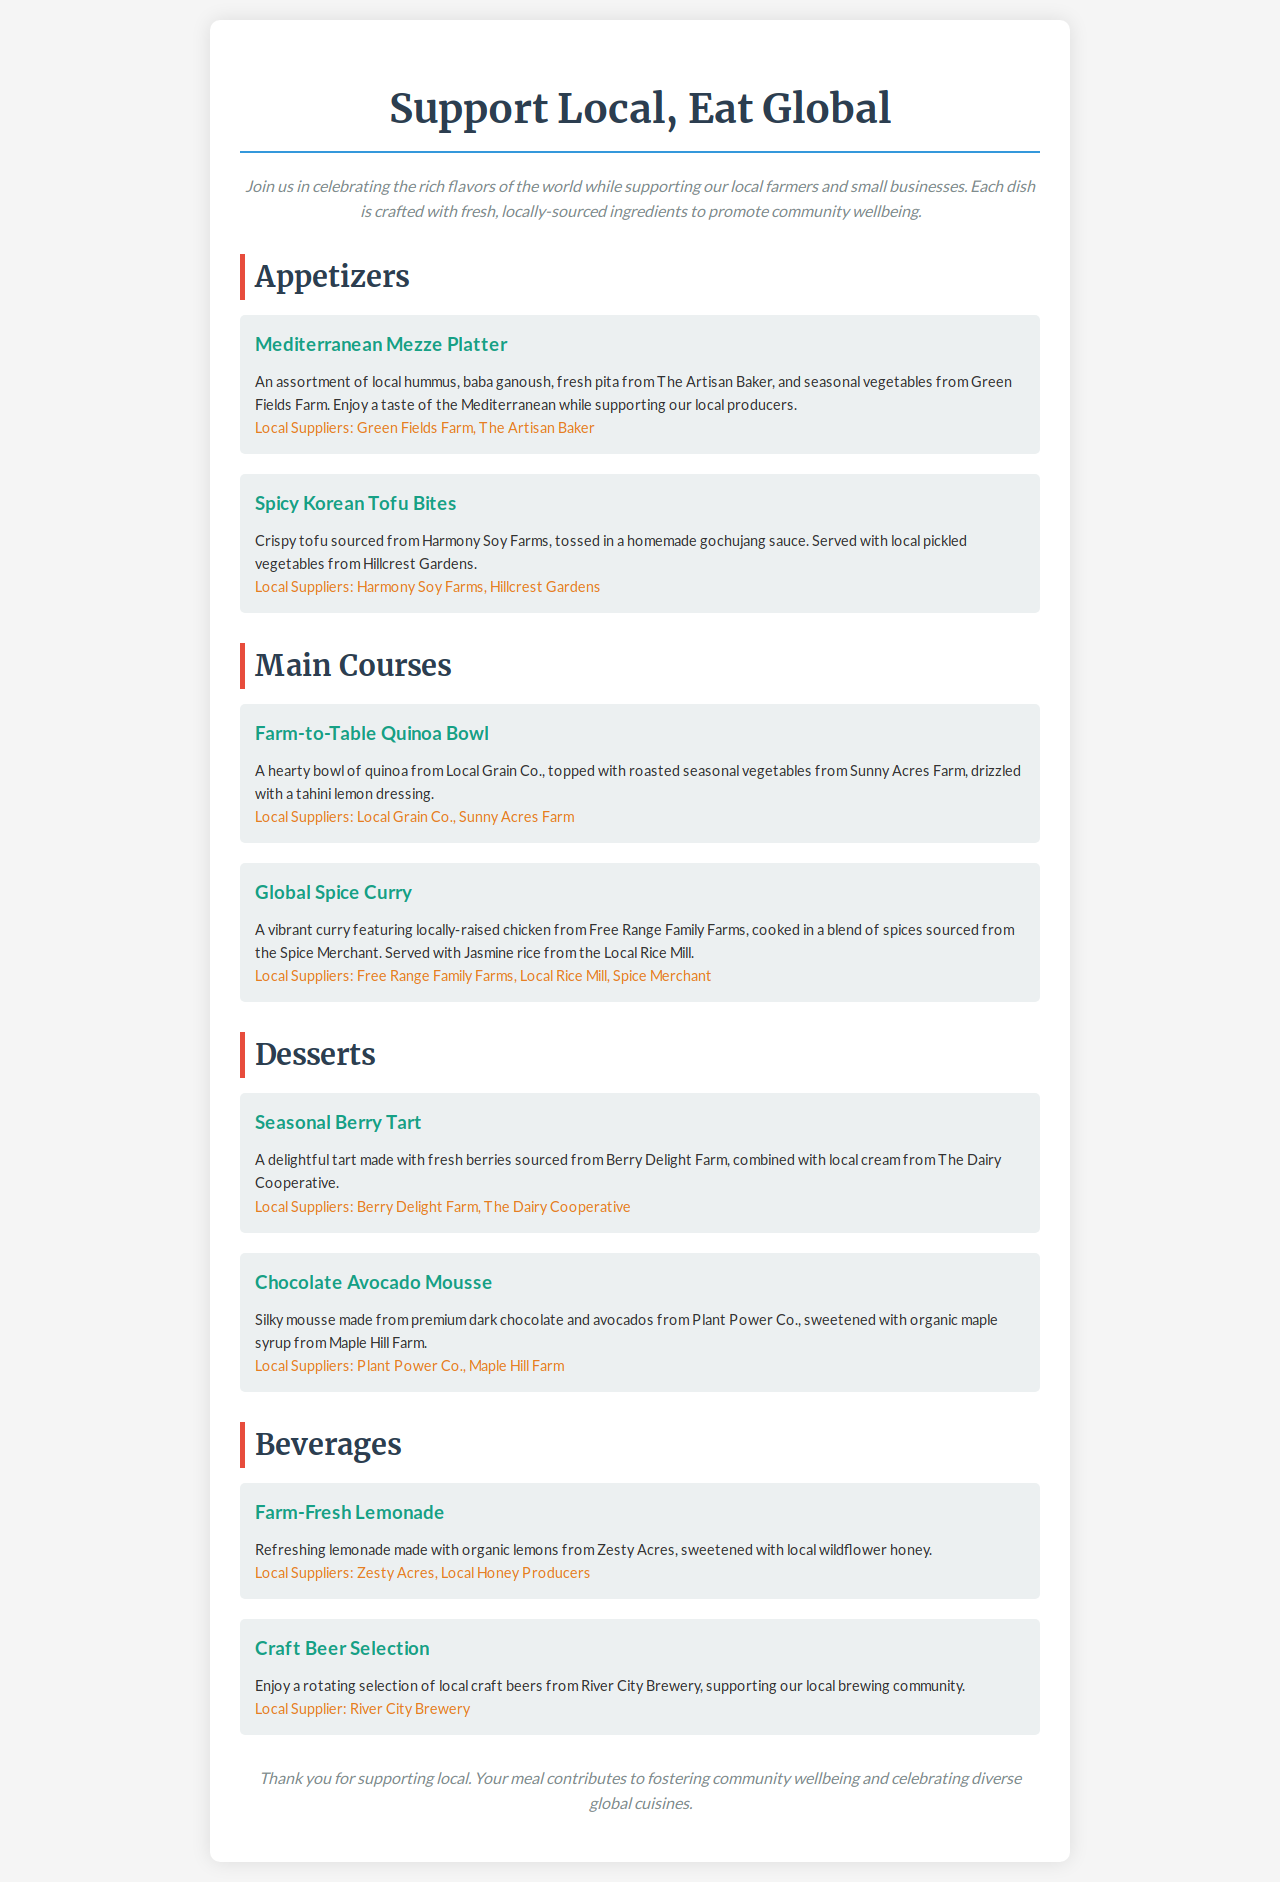What is the title of the menu? The title of the menu is prominently displayed at the top of the document, indicating the theme of the dining experience.
Answer: Support Local, Eat Global Who provides the fresh pita for the Mediterranean Mezze Platter? The supplier for the fresh pita is mentioned under the description of the Mediterranean Mezze Platter.
Answer: The Artisan Baker What kind of dressing is used in the Farm-to-Table Quinoa Bowl? The type of dressing is specified in the dish description for the Farm-to-Table Quinoa Bowl.
Answer: Tahini lemon dressing Which farm supplies the fresh berries for the Seasonal Berry Tart? The farm providing the fresh berries is stated in the description of the Seasonal Berry Tart.
Answer: Berry Delight Farm How many local suppliers are mentioned for the Global Spice Curry? The number of local suppliers is counted based on the listing in the Global Spice Curry item.
Answer: Three What does the Farm-Fresh Lemonade contain? The ingredients for the Farm-Fresh Lemonade are detailed in its description.
Answer: Organic lemons and local wildflower honey Which section comes after Appetizers in the menu? The order of the sections is indicated in the document, showing the flow of offerings.
Answer: Main Courses What type of food is primarily featured in the menu? The overall theme is derived from the dish descriptions and focus on fresh sourcing.
Answer: Globally inspired dishes 